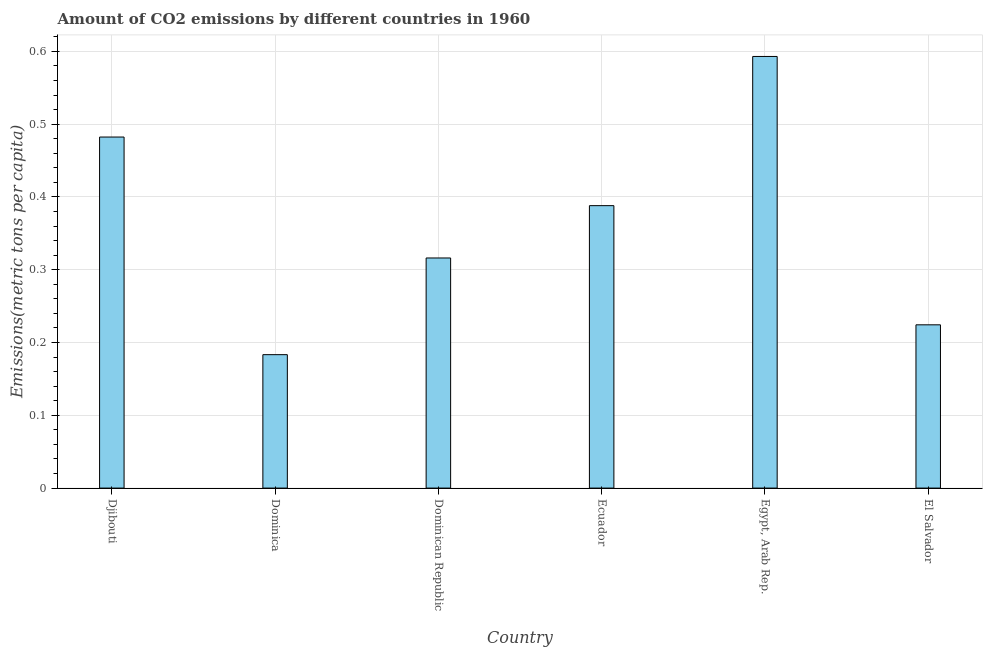Does the graph contain any zero values?
Give a very brief answer. No. Does the graph contain grids?
Your answer should be very brief. Yes. What is the title of the graph?
Your answer should be very brief. Amount of CO2 emissions by different countries in 1960. What is the label or title of the Y-axis?
Make the answer very short. Emissions(metric tons per capita). What is the amount of co2 emissions in El Salvador?
Your response must be concise. 0.22. Across all countries, what is the maximum amount of co2 emissions?
Provide a short and direct response. 0.59. Across all countries, what is the minimum amount of co2 emissions?
Give a very brief answer. 0.18. In which country was the amount of co2 emissions maximum?
Make the answer very short. Egypt, Arab Rep. In which country was the amount of co2 emissions minimum?
Offer a very short reply. Dominica. What is the sum of the amount of co2 emissions?
Provide a short and direct response. 2.19. What is the difference between the amount of co2 emissions in Dominica and Egypt, Arab Rep.?
Give a very brief answer. -0.41. What is the average amount of co2 emissions per country?
Provide a succinct answer. 0.36. What is the median amount of co2 emissions?
Provide a short and direct response. 0.35. What is the ratio of the amount of co2 emissions in Dominica to that in Dominican Republic?
Give a very brief answer. 0.58. Is the difference between the amount of co2 emissions in Ecuador and Egypt, Arab Rep. greater than the difference between any two countries?
Ensure brevity in your answer.  No. What is the difference between the highest and the second highest amount of co2 emissions?
Ensure brevity in your answer.  0.11. What is the difference between the highest and the lowest amount of co2 emissions?
Provide a succinct answer. 0.41. How many countries are there in the graph?
Provide a succinct answer. 6. What is the difference between two consecutive major ticks on the Y-axis?
Your answer should be compact. 0.1. What is the Emissions(metric tons per capita) in Djibouti?
Provide a short and direct response. 0.48. What is the Emissions(metric tons per capita) in Dominica?
Make the answer very short. 0.18. What is the Emissions(metric tons per capita) in Dominican Republic?
Offer a terse response. 0.32. What is the Emissions(metric tons per capita) in Ecuador?
Your response must be concise. 0.39. What is the Emissions(metric tons per capita) in Egypt, Arab Rep.?
Provide a succinct answer. 0.59. What is the Emissions(metric tons per capita) of El Salvador?
Provide a short and direct response. 0.22. What is the difference between the Emissions(metric tons per capita) in Djibouti and Dominica?
Your answer should be compact. 0.3. What is the difference between the Emissions(metric tons per capita) in Djibouti and Dominican Republic?
Keep it short and to the point. 0.17. What is the difference between the Emissions(metric tons per capita) in Djibouti and Ecuador?
Your answer should be compact. 0.09. What is the difference between the Emissions(metric tons per capita) in Djibouti and Egypt, Arab Rep.?
Your response must be concise. -0.11. What is the difference between the Emissions(metric tons per capita) in Djibouti and El Salvador?
Make the answer very short. 0.26. What is the difference between the Emissions(metric tons per capita) in Dominica and Dominican Republic?
Offer a very short reply. -0.13. What is the difference between the Emissions(metric tons per capita) in Dominica and Ecuador?
Provide a succinct answer. -0.2. What is the difference between the Emissions(metric tons per capita) in Dominica and Egypt, Arab Rep.?
Provide a short and direct response. -0.41. What is the difference between the Emissions(metric tons per capita) in Dominica and El Salvador?
Your answer should be very brief. -0.04. What is the difference between the Emissions(metric tons per capita) in Dominican Republic and Ecuador?
Ensure brevity in your answer.  -0.07. What is the difference between the Emissions(metric tons per capita) in Dominican Republic and Egypt, Arab Rep.?
Give a very brief answer. -0.28. What is the difference between the Emissions(metric tons per capita) in Dominican Republic and El Salvador?
Ensure brevity in your answer.  0.09. What is the difference between the Emissions(metric tons per capita) in Ecuador and Egypt, Arab Rep.?
Make the answer very short. -0.2. What is the difference between the Emissions(metric tons per capita) in Ecuador and El Salvador?
Provide a short and direct response. 0.16. What is the difference between the Emissions(metric tons per capita) in Egypt, Arab Rep. and El Salvador?
Give a very brief answer. 0.37. What is the ratio of the Emissions(metric tons per capita) in Djibouti to that in Dominica?
Offer a terse response. 2.63. What is the ratio of the Emissions(metric tons per capita) in Djibouti to that in Dominican Republic?
Ensure brevity in your answer.  1.52. What is the ratio of the Emissions(metric tons per capita) in Djibouti to that in Ecuador?
Your response must be concise. 1.24. What is the ratio of the Emissions(metric tons per capita) in Djibouti to that in Egypt, Arab Rep.?
Make the answer very short. 0.81. What is the ratio of the Emissions(metric tons per capita) in Djibouti to that in El Salvador?
Offer a terse response. 2.15. What is the ratio of the Emissions(metric tons per capita) in Dominica to that in Dominican Republic?
Ensure brevity in your answer.  0.58. What is the ratio of the Emissions(metric tons per capita) in Dominica to that in Ecuador?
Provide a succinct answer. 0.47. What is the ratio of the Emissions(metric tons per capita) in Dominica to that in Egypt, Arab Rep.?
Offer a terse response. 0.31. What is the ratio of the Emissions(metric tons per capita) in Dominica to that in El Salvador?
Ensure brevity in your answer.  0.82. What is the ratio of the Emissions(metric tons per capita) in Dominican Republic to that in Ecuador?
Provide a succinct answer. 0.81. What is the ratio of the Emissions(metric tons per capita) in Dominican Republic to that in Egypt, Arab Rep.?
Your answer should be very brief. 0.53. What is the ratio of the Emissions(metric tons per capita) in Dominican Republic to that in El Salvador?
Give a very brief answer. 1.41. What is the ratio of the Emissions(metric tons per capita) in Ecuador to that in Egypt, Arab Rep.?
Make the answer very short. 0.65. What is the ratio of the Emissions(metric tons per capita) in Ecuador to that in El Salvador?
Your answer should be compact. 1.73. What is the ratio of the Emissions(metric tons per capita) in Egypt, Arab Rep. to that in El Salvador?
Make the answer very short. 2.64. 